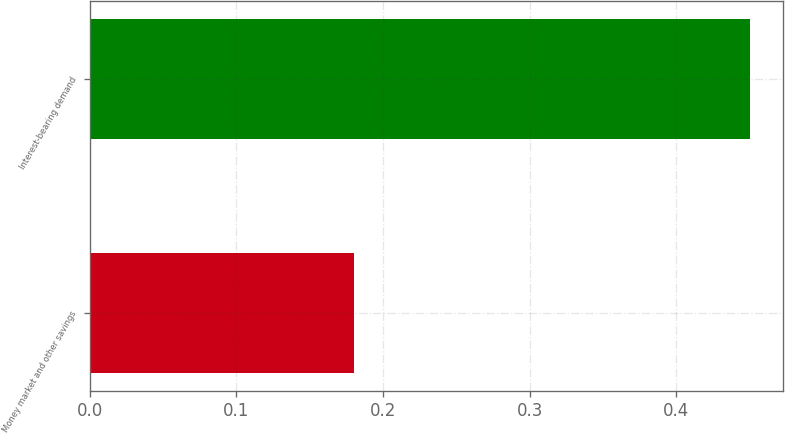Convert chart to OTSL. <chart><loc_0><loc_0><loc_500><loc_500><bar_chart><fcel>Money market and other savings<fcel>Interest-bearing demand<nl><fcel>0.18<fcel>0.45<nl></chart> 